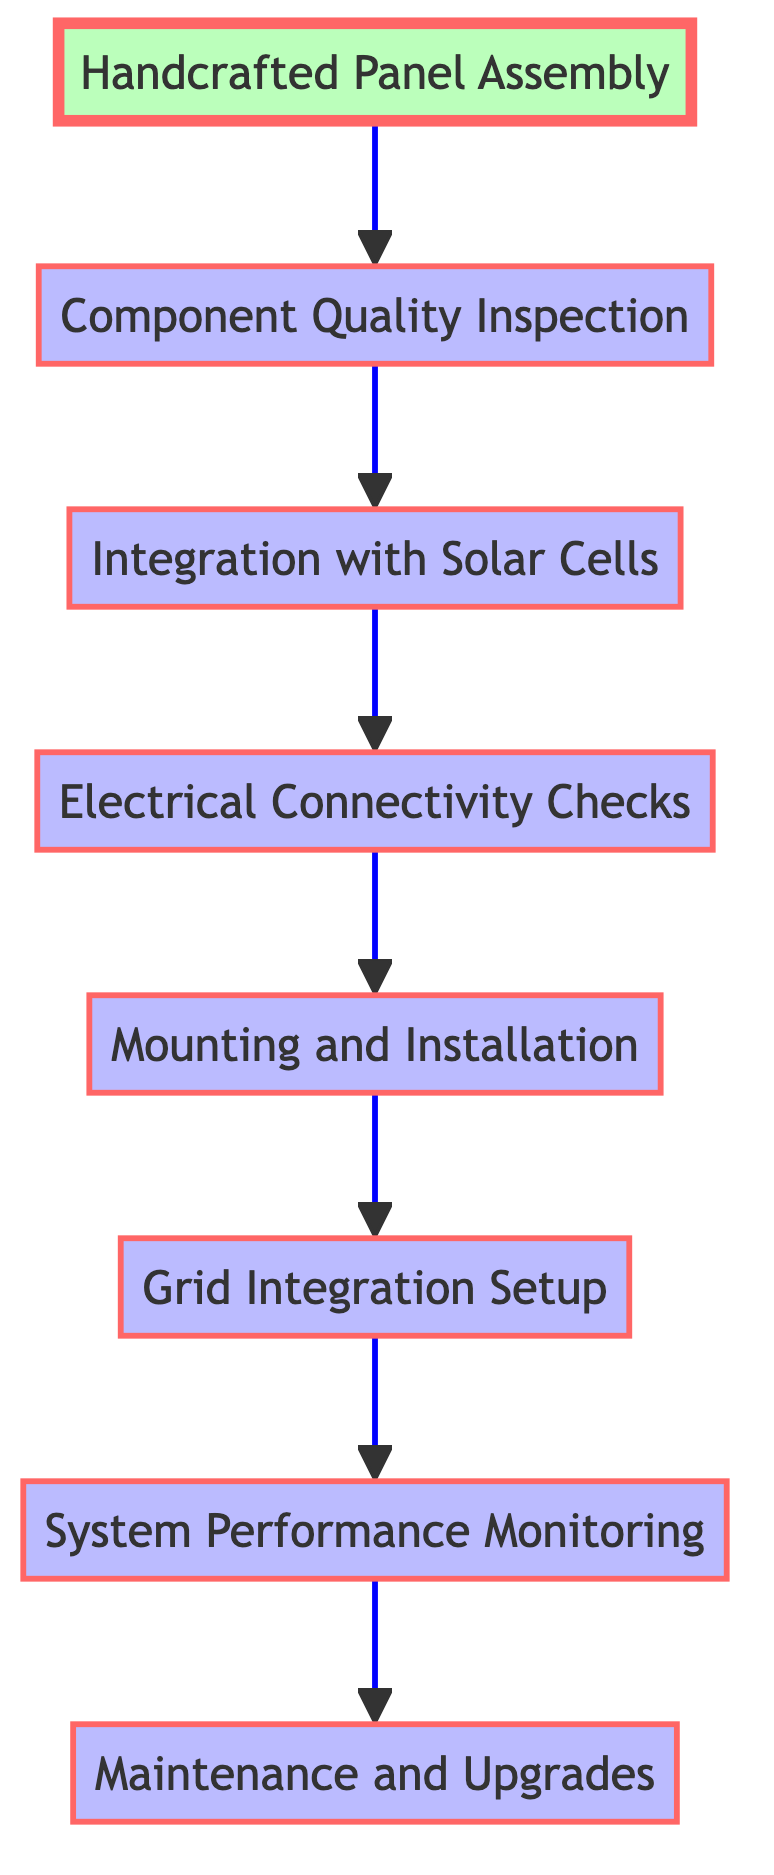What is the first step in the process? The first step in the flow chart is "Handcrafted Panel Assembly," which involves constructing solar panel frames using handcrafted techniques and sustainable materials.
Answer: Handcrafted Panel Assembly How many steps are there in total? Counting each distinct node in the diagram, there are a total of eight steps, starting from "Handcrafted Panel Assembly" to "Maintenance and Upgrades."
Answer: 8 What is the output of the "Grid Integration Setup"? The output from the "Grid Integration Setup" step is "Grid-Connected Handcrafted Solar Panels," which means the panels are now linked to the local energy grid.
Answer: Grid-Connected Handcrafted Solar Panels What step comes before "System Performance Monitoring"? The step that comes immediately before "System Performance Monitoring" is "Grid Integration Setup," where the installed panels are linked to the local energy grid.
Answer: Grid Integration Setup Which step focuses on ensuring component quality? The step that concentrates on ensuring each component meets durability and sustainability standards is "Component Quality Inspection."
Answer: Component Quality Inspection What is the output of the final step? The output of the final step, "Maintenance and Upgrades," is "Optimized Panel Performance," indicating improved efficiency after routine checks and improvements.
Answer: Optimized Panel Performance In which step are the solar cells integrated? The integration of high-efficiency solar cells into the handcrafted frames occurs at the "Integration with Solar Cells" step, which follows the quality inspection.
Answer: Integration with Solar Cells What is the input for the "Electrical Connectivity Checks"? The input for the "Electrical Connectivity Checks" step is "Functional Handcrafted Solar Panels," indicating that the panels are ready for testing connectivity and system integration.
Answer: Functional Handcrafted Solar Panels 